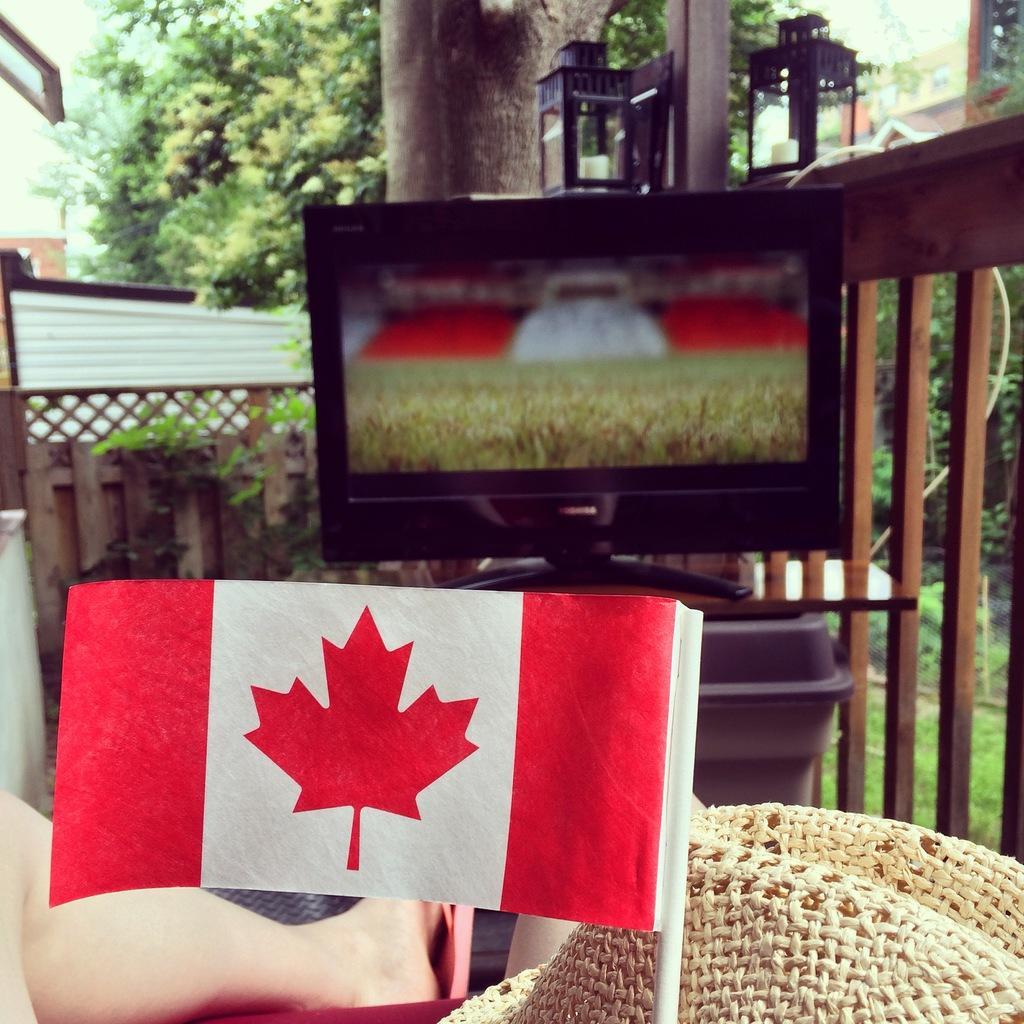Can you describe this image briefly? In this picture I can see a flag at the bottom, on the left side there is a human leg. In the middle there is a television, in the background there are trees and buildings. On the right side it looks like a wooden railing. 